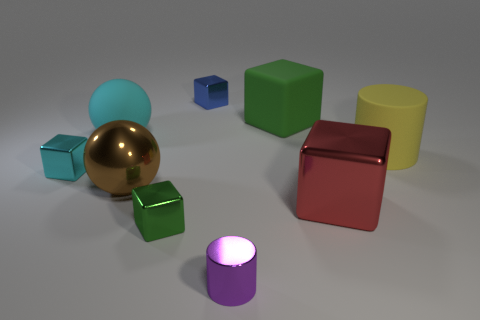Are there the same number of cyan metal blocks behind the large green matte thing and purple matte cylinders?
Offer a very short reply. Yes. There is a large green rubber block; are there any tiny metallic cylinders in front of it?
Make the answer very short. Yes. There is a blue metal object; does it have the same shape as the large thing that is behind the cyan rubber sphere?
Your answer should be compact. Yes. There is a ball that is the same material as the tiny purple cylinder; what color is it?
Provide a short and direct response. Brown. What color is the tiny metal cylinder?
Offer a terse response. Purple. Does the tiny purple cylinder have the same material as the small cube left of the green shiny block?
Keep it short and to the point. Yes. What number of large things are to the right of the large metallic ball and behind the cyan cube?
Make the answer very short. 2. There is a green thing that is the same size as the red thing; what shape is it?
Provide a succinct answer. Cube. There is a green block behind the big metal thing to the left of the purple metal object; is there a tiny green shiny object behind it?
Ensure brevity in your answer.  No. Does the big rubber cube have the same color as the big shiny object that is to the left of the big green rubber cube?
Keep it short and to the point. No. 